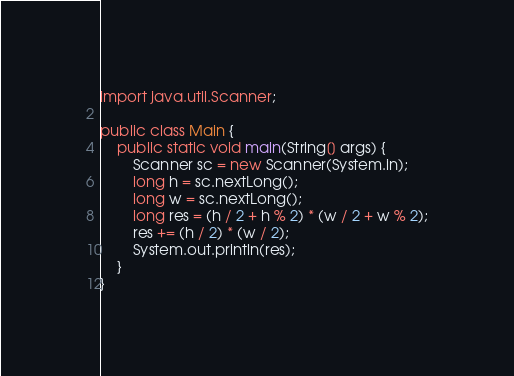<code> <loc_0><loc_0><loc_500><loc_500><_Java_>import java.util.Scanner;

public class Main {
	public static void main(String[] args) {
		Scanner sc = new Scanner(System.in);
		long h = sc.nextLong();
		long w = sc.nextLong();
		long res = (h / 2 + h % 2) * (w / 2 + w % 2);
		res += (h / 2) * (w / 2);
		System.out.println(res);
	}
}
</code> 